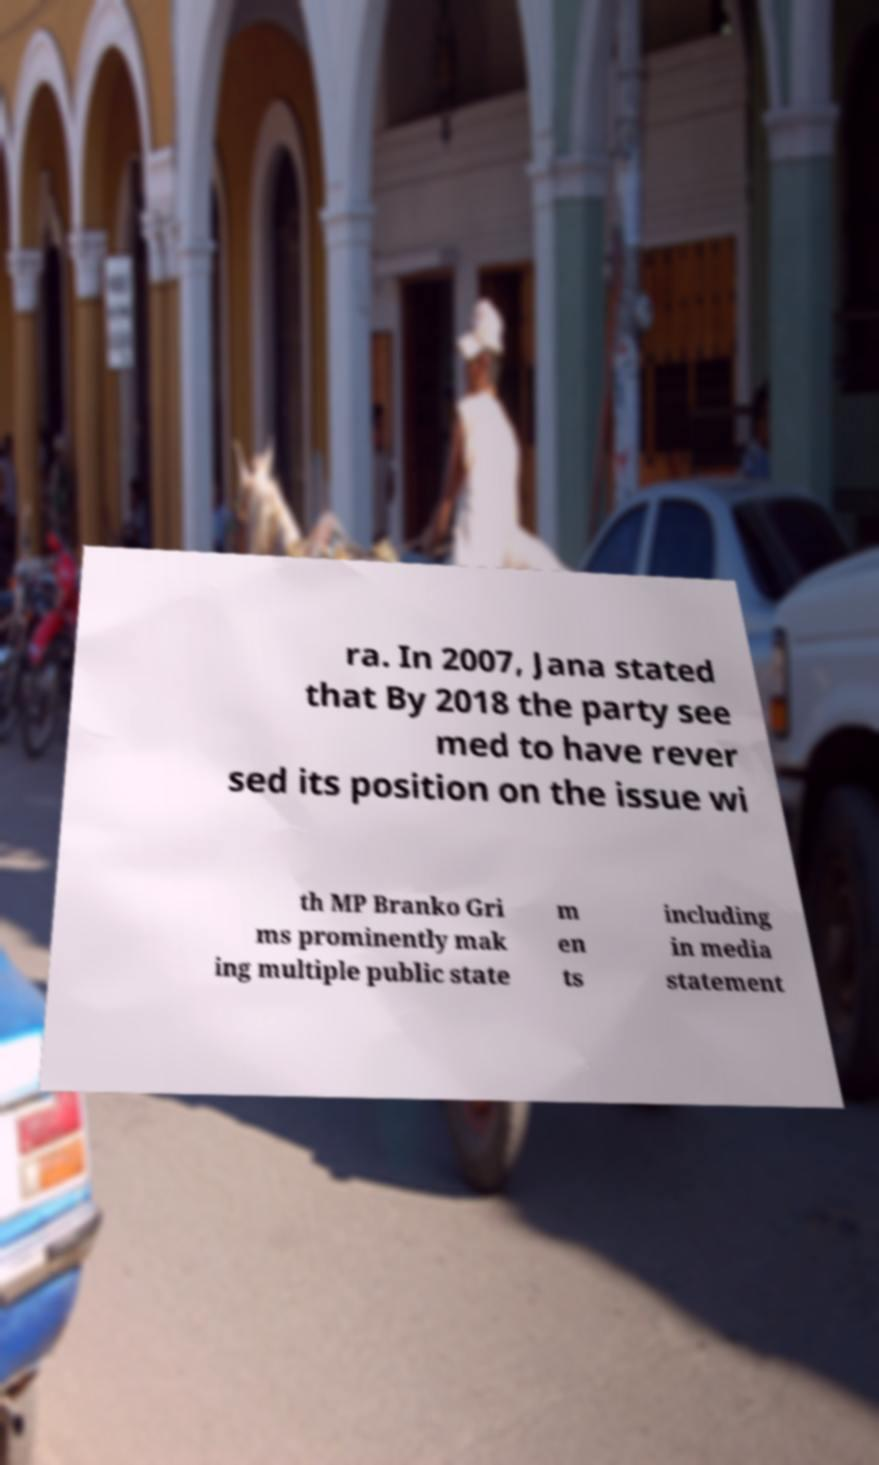For documentation purposes, I need the text within this image transcribed. Could you provide that? ra. In 2007, Jana stated that By 2018 the party see med to have rever sed its position on the issue wi th MP Branko Gri ms prominently mak ing multiple public state m en ts including in media statement 